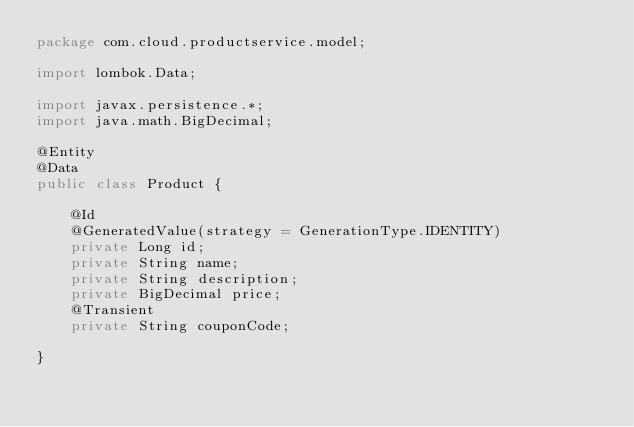<code> <loc_0><loc_0><loc_500><loc_500><_Java_>package com.cloud.productservice.model;

import lombok.Data;

import javax.persistence.*;
import java.math.BigDecimal;

@Entity
@Data
public class Product {

    @Id
    @GeneratedValue(strategy = GenerationType.IDENTITY)
    private Long id;
    private String name;
    private String description;
    private BigDecimal price;
    @Transient
    private String couponCode;

}
</code> 